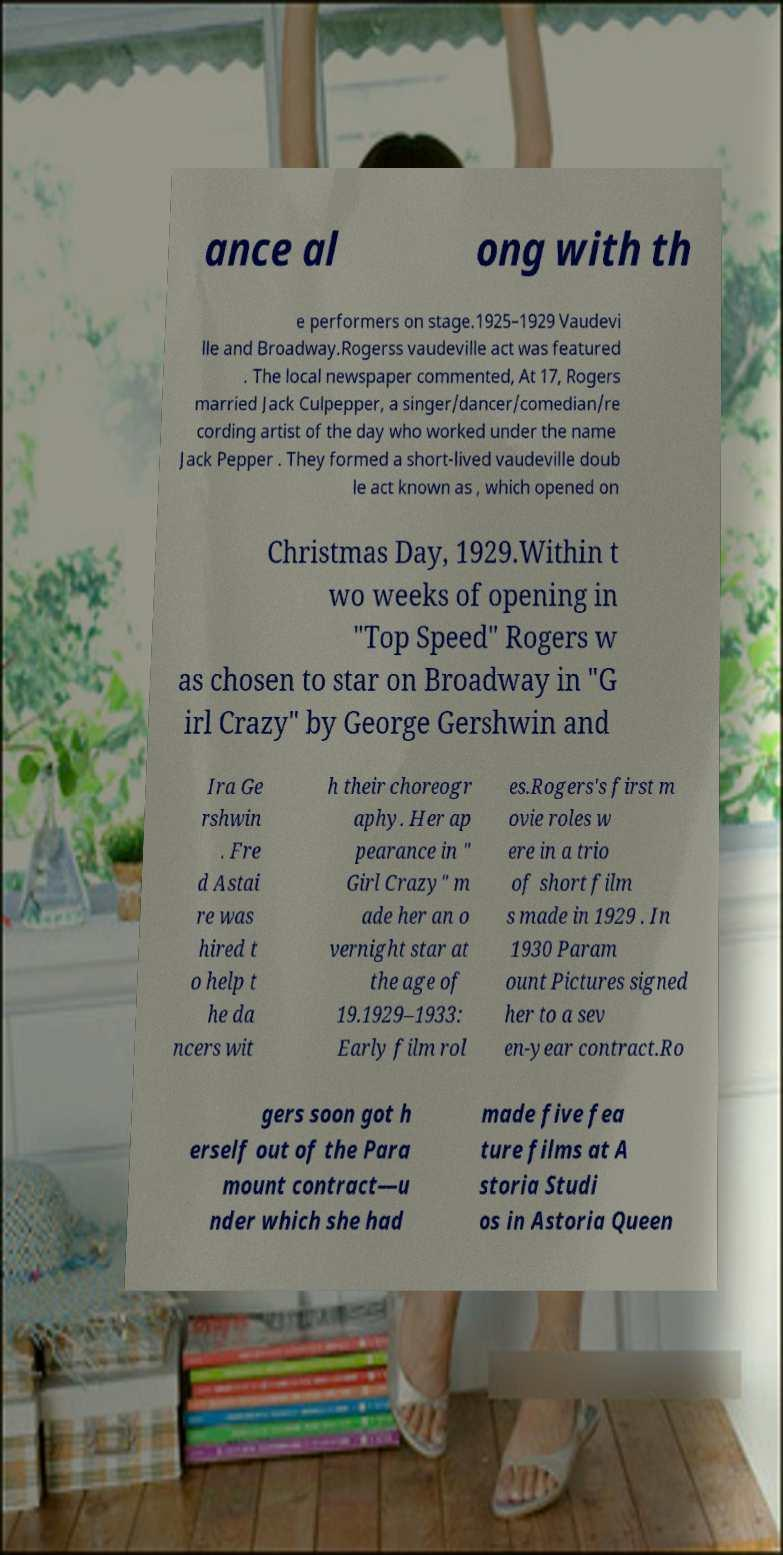I need the written content from this picture converted into text. Can you do that? ance al ong with th e performers on stage.1925–1929 Vaudevi lle and Broadway.Rogerss vaudeville act was featured . The local newspaper commented, At 17, Rogers married Jack Culpepper, a singer/dancer/comedian/re cording artist of the day who worked under the name Jack Pepper . They formed a short-lived vaudeville doub le act known as , which opened on Christmas Day, 1929.Within t wo weeks of opening in "Top Speed" Rogers w as chosen to star on Broadway in "G irl Crazy" by George Gershwin and Ira Ge rshwin . Fre d Astai re was hired t o help t he da ncers wit h their choreogr aphy. Her ap pearance in " Girl Crazy" m ade her an o vernight star at the age of 19.1929–1933: Early film rol es.Rogers's first m ovie roles w ere in a trio of short film s made in 1929 . In 1930 Param ount Pictures signed her to a sev en-year contract.Ro gers soon got h erself out of the Para mount contract—u nder which she had made five fea ture films at A storia Studi os in Astoria Queen 